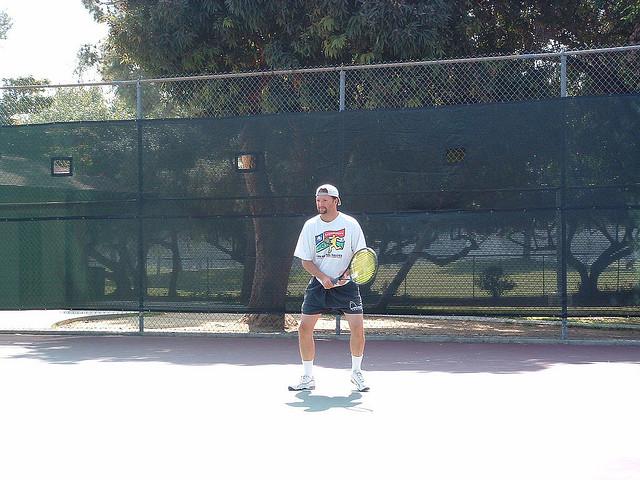What color are his socks?
Quick response, please. White. What sport is the guy in the picture playing?
Short answer required. Tennis. What is in the man's hand?
Give a very brief answer. Racket. 